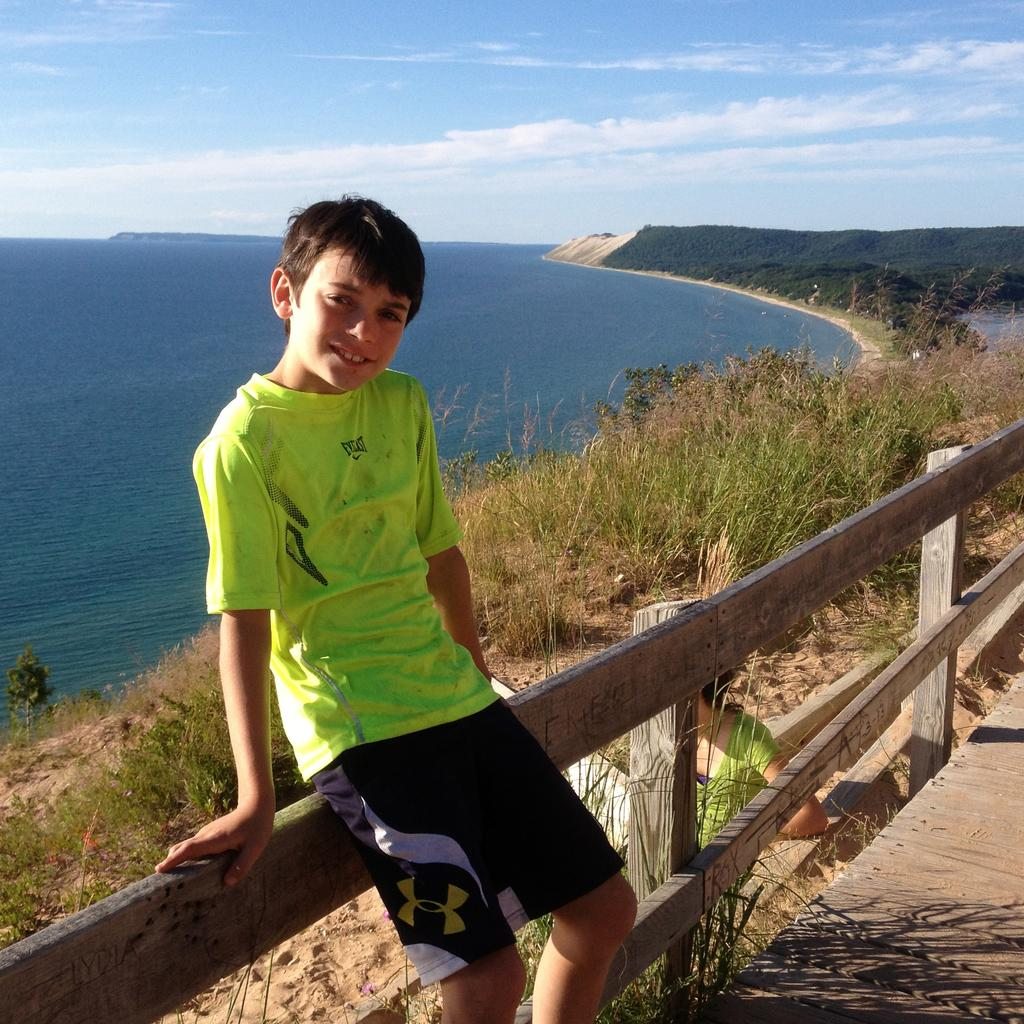<image>
Give a short and clear explanation of the subsequent image. a boy sitting on a fence overlooking a body of water in an everlast shirt 